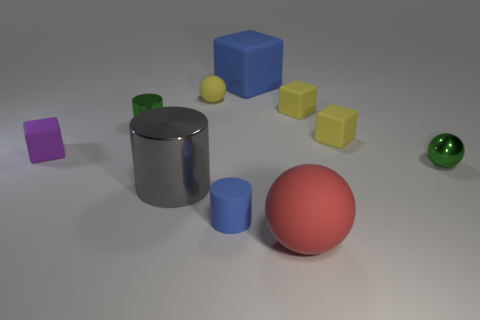Subtract all spheres. How many objects are left? 7 Subtract 3 cylinders. How many cylinders are left? 0 Subtract all yellow balls. Subtract all blue cubes. How many balls are left? 2 Subtract all brown cubes. How many purple cylinders are left? 0 Subtract all matte blocks. Subtract all brown matte spheres. How many objects are left? 6 Add 3 rubber cylinders. How many rubber cylinders are left? 4 Add 5 yellow spheres. How many yellow spheres exist? 6 Subtract all blue cubes. How many cubes are left? 3 Subtract all large matte spheres. How many spheres are left? 2 Subtract 0 cyan cylinders. How many objects are left? 10 